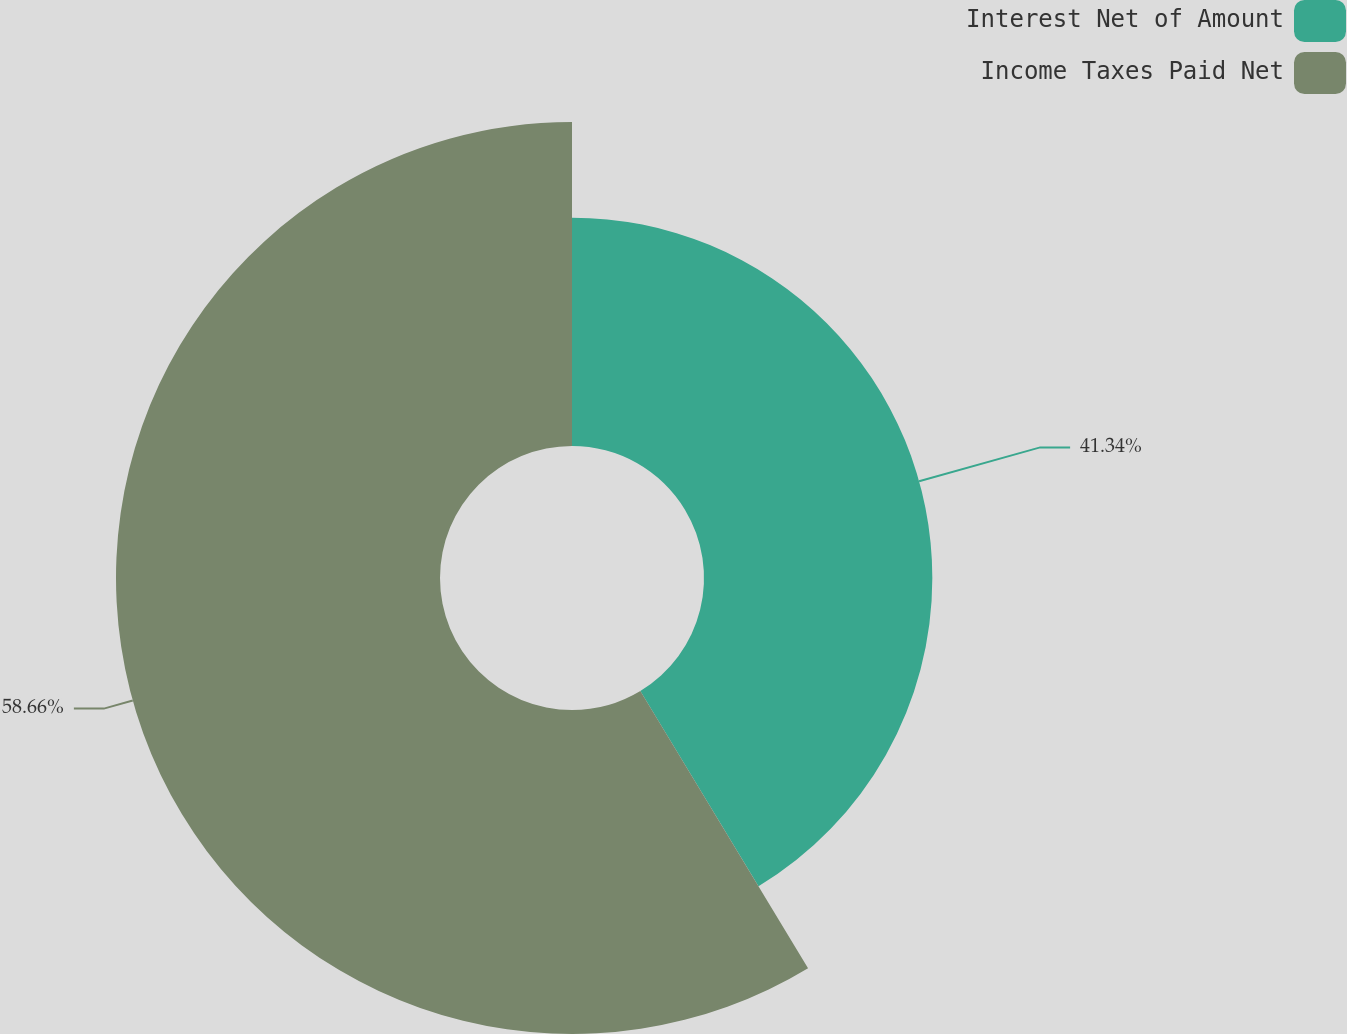Convert chart to OTSL. <chart><loc_0><loc_0><loc_500><loc_500><pie_chart><fcel>Interest Net of Amount<fcel>Income Taxes Paid Net<nl><fcel>41.34%<fcel>58.66%<nl></chart> 